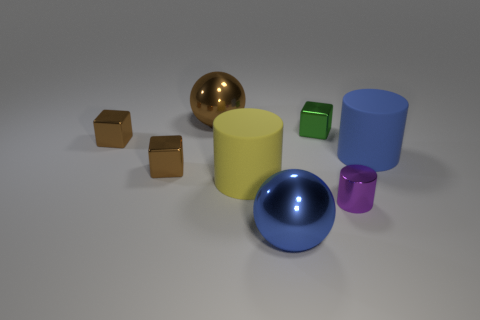Add 2 large gray matte balls. How many objects exist? 10 Subtract all balls. How many objects are left? 6 Subtract 0 gray cylinders. How many objects are left? 8 Subtract all blue metal spheres. Subtract all large blue spheres. How many objects are left? 6 Add 5 green objects. How many green objects are left? 6 Add 1 tiny metallic things. How many tiny metallic things exist? 5 